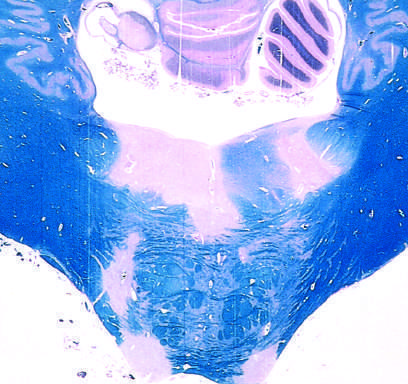does the blood-brain barrier stain for myelin?
Answer the question using a single word or phrase. No 